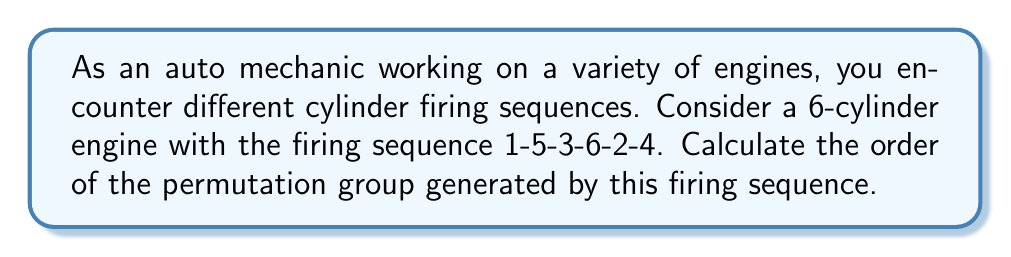Teach me how to tackle this problem. To solve this problem, we'll follow these steps:

1) First, let's write the permutation in cycle notation:
   $$(1\,5\,2\,4\,6\,3)$$

2) The order of a permutation is the least common multiple (LCM) of the lengths of its disjoint cycles. In this case, we have a single cycle of length 6.

3) Therefore, the order of this permutation is simply 6.

4) Now, we need to consider the group generated by this permutation. Let's call our permutation $\sigma$. The group will consist of:

   $\{\sigma^0, \sigma^1, \sigma^2, \sigma^3, \sigma^4, \sigma^5\}$

   Where $\sigma^0$ is the identity permutation.

5) We can verify that $\sigma^6 = \sigma^0$ (the identity), and no smaller power of $\sigma$ equals the identity.

6) Therefore, the group generated by this permutation is cyclic of order 6.

This result aligns with the fact that after 6 firings, we return to the first cylinder, completing one full cycle of the engine.
Answer: The order of the permutation group generated by the firing sequence 1-5-3-6-2-4 is 6. 